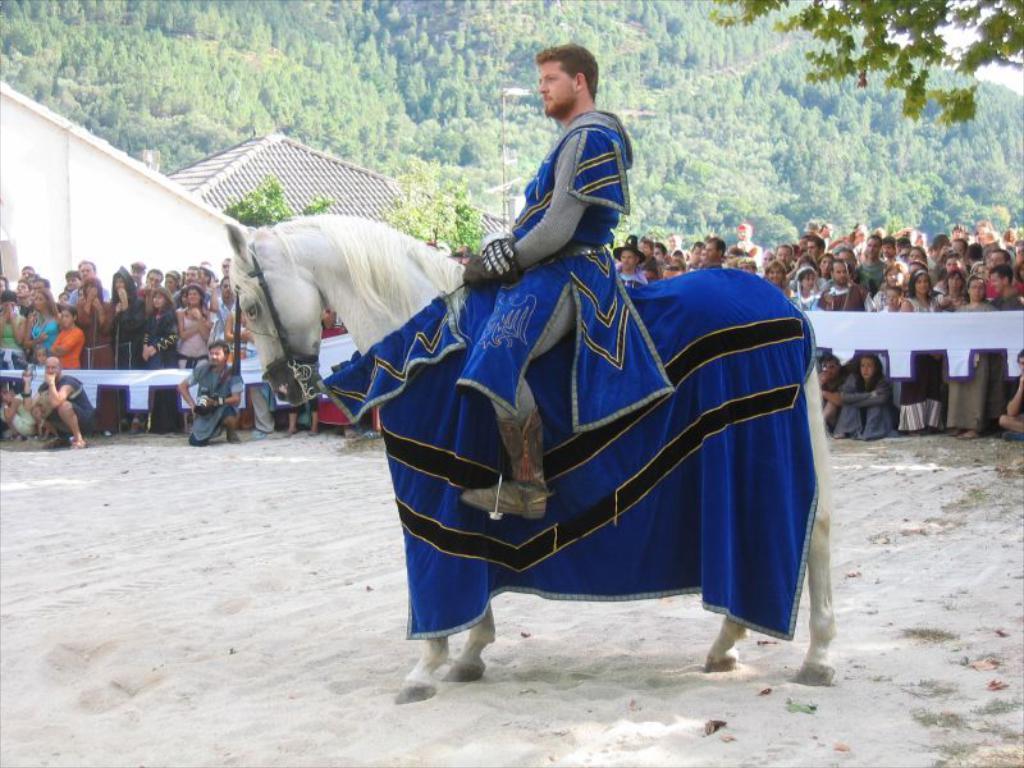Please provide a concise description of this image. In this picture there is a man in the center of the image, on a horse, on a muddy floor and there are people those who are standing in front of the boundary in the background area of the image, there is a pole, houses, and trees in the background area of the image. 